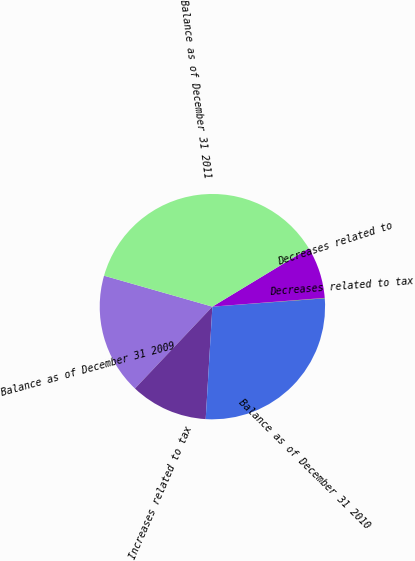Convert chart to OTSL. <chart><loc_0><loc_0><loc_500><loc_500><pie_chart><fcel>Balance as of December 31 2009<fcel>Increases related to tax<fcel>Balance as of December 31 2010<fcel>Decreases related to tax<fcel>Decreases related to<fcel>Balance as of December 31 2011<nl><fcel>17.37%<fcel>11.11%<fcel>27.12%<fcel>0.06%<fcel>7.43%<fcel>36.9%<nl></chart> 